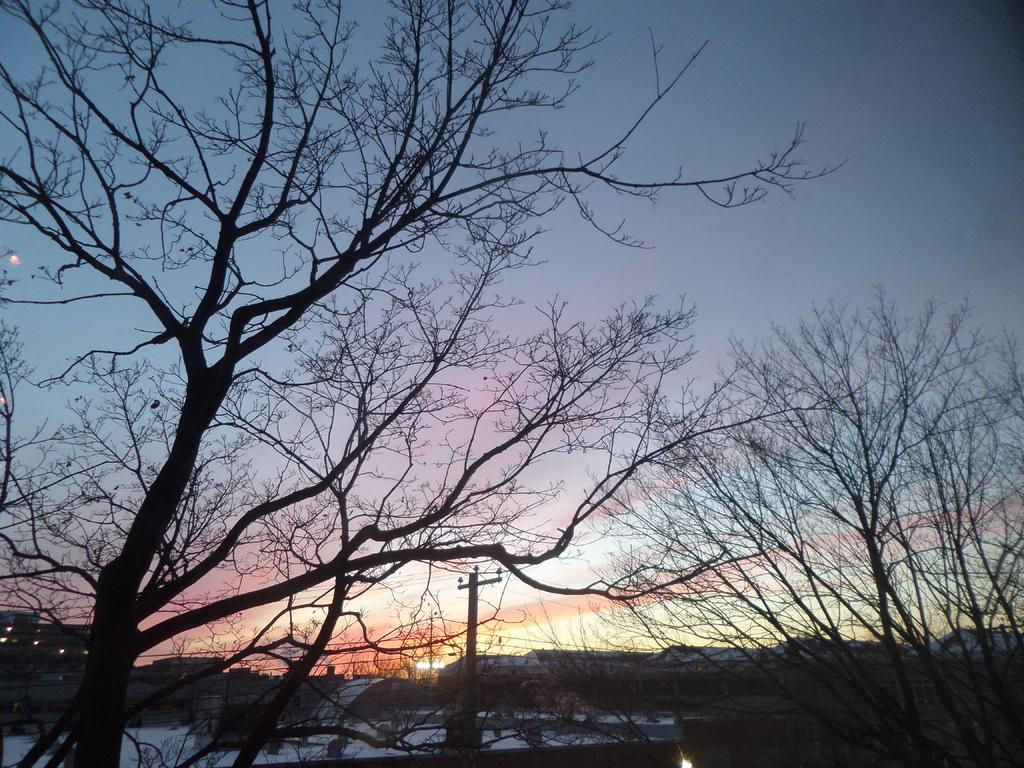What type of vegetation can be seen in the image? There are trees in the image. What is attached to the electrical pole in the image? There are cables attached to the electrical pole in the image. What type of structures are visible in the image? There are buildings in the image. What is the condition of the ground in the image? The ground is covered in snow in the image. What is visible in the sky in the image? The sky is clear in the image. How many cows are visible in the image? There are no cows present in the image. What is the girl doing in the image? There is no girl present in the image. 